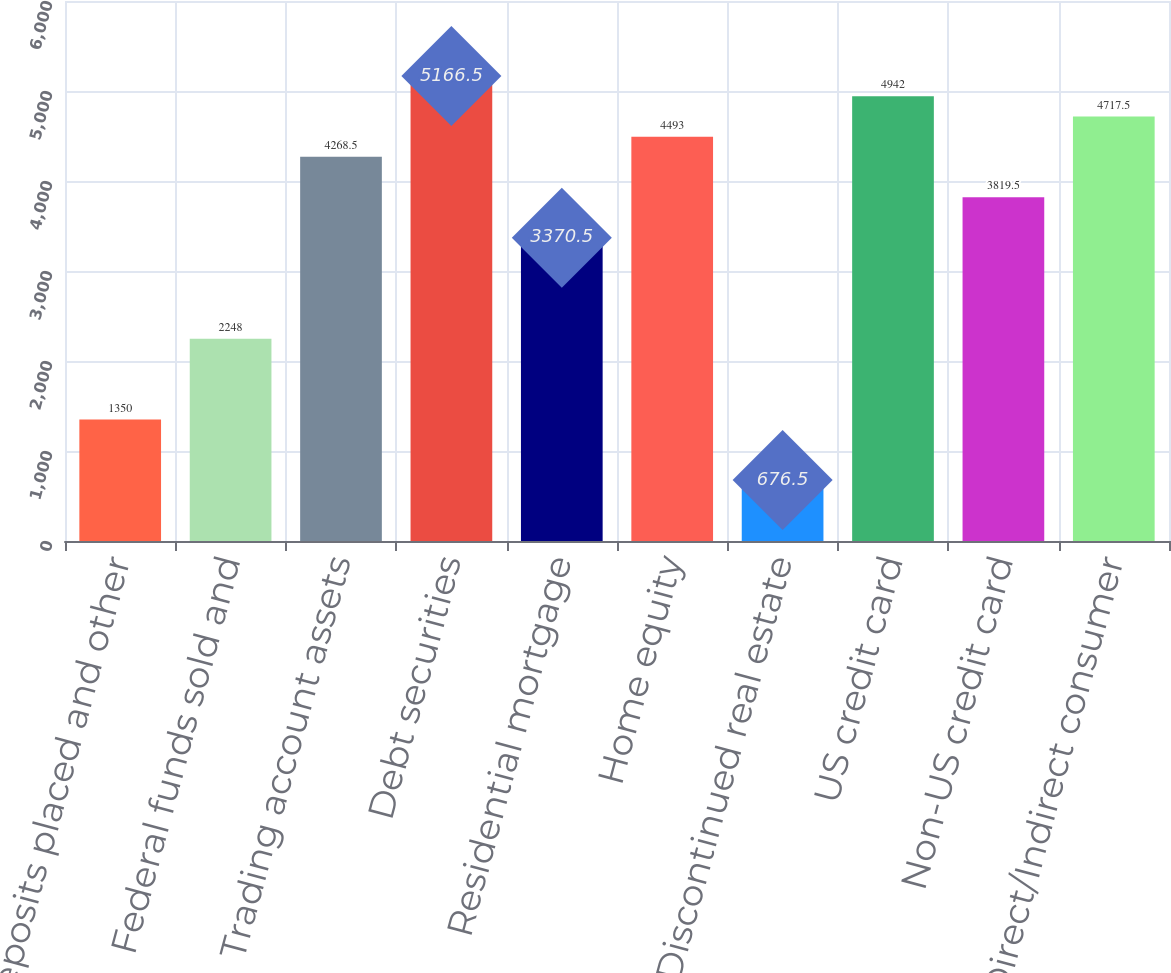Convert chart. <chart><loc_0><loc_0><loc_500><loc_500><bar_chart><fcel>Time deposits placed and other<fcel>Federal funds sold and<fcel>Trading account assets<fcel>Debt securities<fcel>Residential mortgage<fcel>Home equity<fcel>Discontinued real estate<fcel>US credit card<fcel>Non-US credit card<fcel>Direct/Indirect consumer<nl><fcel>1350<fcel>2248<fcel>4268.5<fcel>5166.5<fcel>3370.5<fcel>4493<fcel>676.5<fcel>4942<fcel>3819.5<fcel>4717.5<nl></chart> 